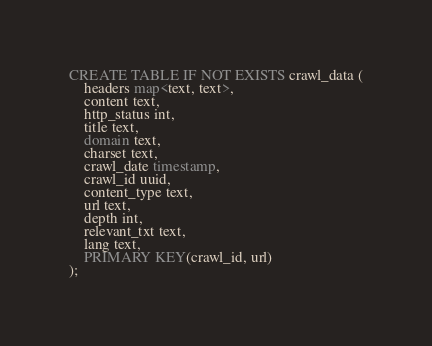Convert code to text. <code><loc_0><loc_0><loc_500><loc_500><_SQL_>CREATE TABLE IF NOT EXISTS crawl_data (
    headers map<text, text>,
    content text,
    http_status int,
    title text,
    domain text,
    charset text,
    crawl_date timestamp,
    crawl_id uuid,
    content_type text,
    url text,
    depth int,
    relevant_txt text,
    lang text,
    PRIMARY KEY(crawl_id, url)
);
</code> 